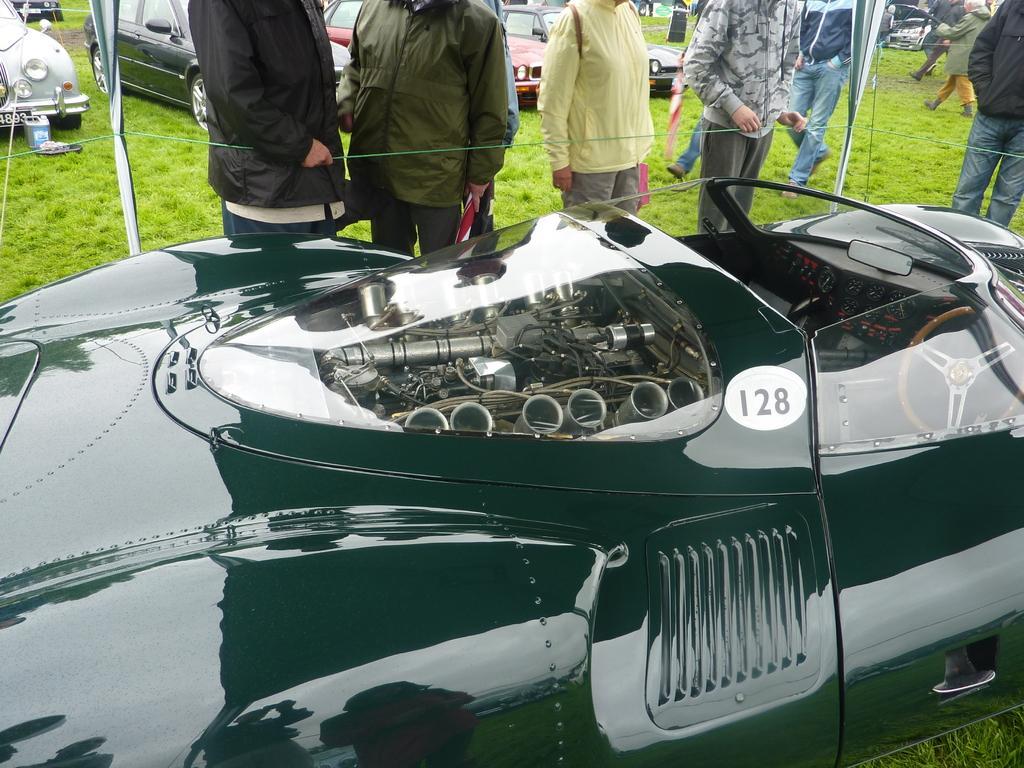Please provide a concise description of this image. In this picture there are vehicles and there are group of people standing behind the vehicle and there are group of people walking. At the bottom there is grass. There is a reflection of group of people and trees on the vehicle. 